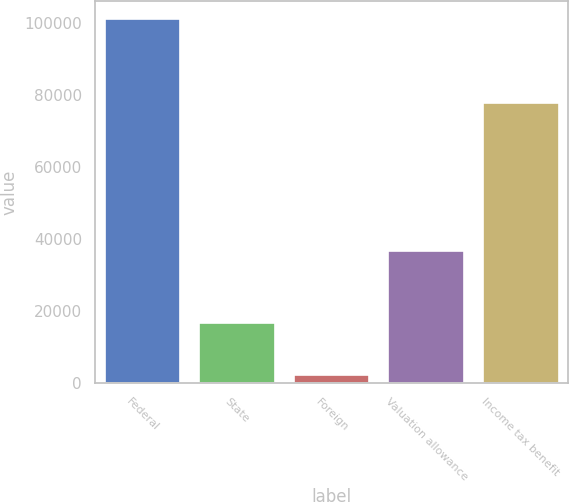Convert chart. <chart><loc_0><loc_0><loc_500><loc_500><bar_chart><fcel>Federal<fcel>State<fcel>Foreign<fcel>Valuation allowance<fcel>Income tax benefit<nl><fcel>100986<fcel>16763<fcel>2456<fcel>36603<fcel>77796<nl></chart> 